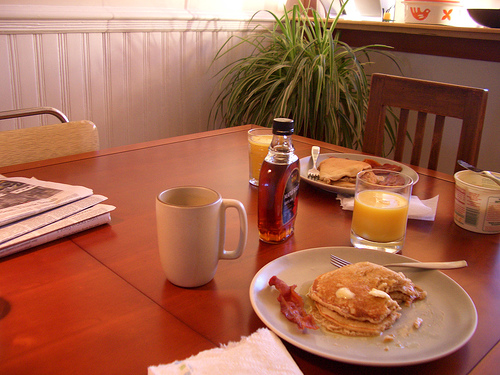<image>
Is the syrup next to the butter tub? No. The syrup is not positioned next to the butter tub. They are located in different areas of the scene. Where is the plant in relation to the syrup? Is it above the syrup? No. The plant is not positioned above the syrup. The vertical arrangement shows a different relationship. 